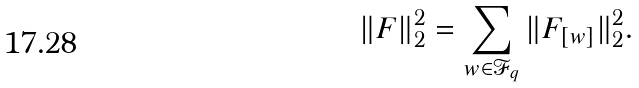<formula> <loc_0><loc_0><loc_500><loc_500>\| F \| _ { 2 } ^ { 2 } = \sum _ { w \in \mathcal { F } _ { q } } \| F _ { [ w ] } \| _ { 2 } ^ { 2 } .</formula> 